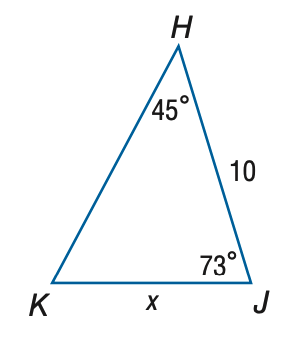Question: Find x. Round to the nearest tenth.
Choices:
A. 7.4
B. 8.0
C. 12.5
D. 13.5
Answer with the letter. Answer: B 